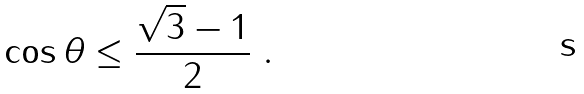<formula> <loc_0><loc_0><loc_500><loc_500>\cos { \theta } \leq \frac { \sqrt { 3 } - 1 } { 2 } \ .</formula> 